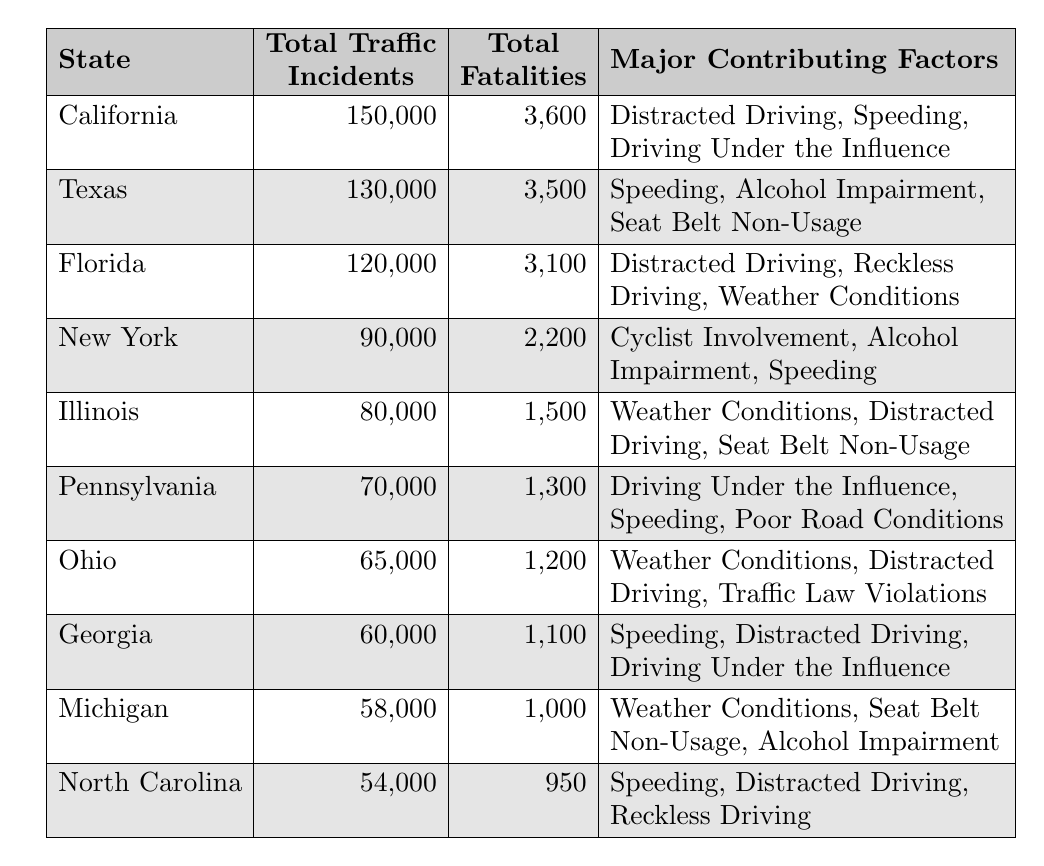What state had the highest number of total traffic incidents in 2021? By examining the table, California has the highest value for total traffic incidents at 150,000.
Answer: California How many total fatalities were reported in Texas? The table indicates that Texas had a total of 3,500 fatalities.
Answer: 3,500 Which major contributing factor is common between Florida and Georgia? Both states list “Speeding” as a major contributing factor in their traffic incidents.
Answer: Speeding What is the total number of traffic incidents reported in Illinois and Pennsylvania combined? To find this value, add the traffic incidents for both states: 80,000 (Illinois) + 70,000 (Pennsylvania) = 150,000.
Answer: 150,000 Is "Alcohol Impairment" a major contributing factor for traffic incidents in New York? Yes, the table shows "Alcohol Impairment" as one of the major contributing factors for New York.
Answer: Yes What percentage of total fatalities in the table were in California? First, sum all the total fatalities: 3,600 + 3,500 + 3,100 + 2,200 + 1,500 + 1,300 + 1,200 + 1,100 + 1,000 + 950 = 19,600. Calculate the percentage: (3,600 / 19,600) * 100 ≈ 18.37%.
Answer: 18.37% In which state is “Seat Belt Non-Usage” listed as a contributing factor? The contributing factor "Seat Belt Non-Usage" is listed for Texas and Illinois in the table.
Answer: Texas, Illinois What is the average number of total fatalities across the states listed in the table? The total fatalities are 3,600 + 3,500 + 3,100 + 2,200 + 1,500 + 1,300 + 1,200 + 1,100 + 1,000 + 950 = 19,600. There are 10 states, so the average is 19,600 / 10 = 1,960.
Answer: 1,960 How many states reported more than 2,000 total fatalities? By reviewing the table, only California (3,600), Texas (3,500), and Florida (3,100) reported more than 2,000 fatalities, totaling 3 states.
Answer: 3 Which state has the lowest number of total traffic incidents, and how many were reported? North Carolina has the lowest number of total traffic incidents reported, at 54,000.
Answer: North Carolina, 54,000 